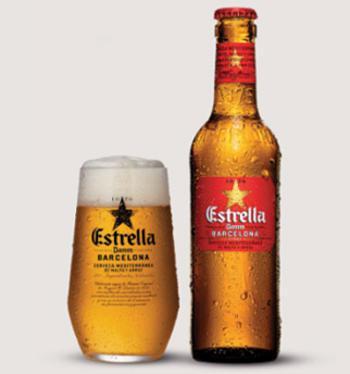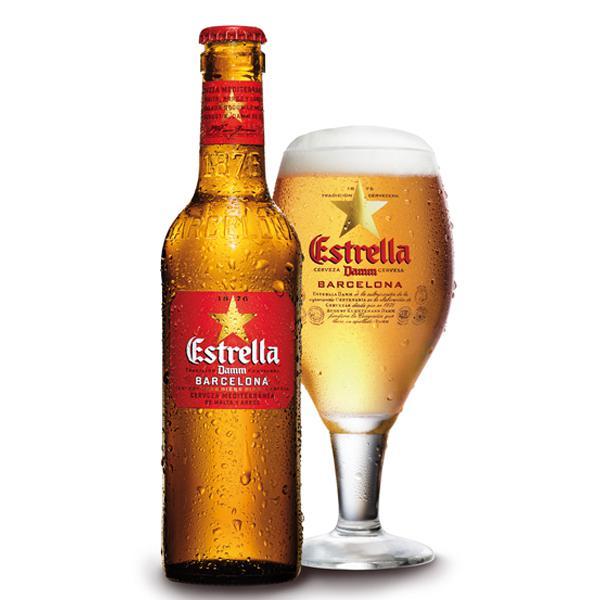The first image is the image on the left, the second image is the image on the right. Given the left and right images, does the statement "Right and left images show the same number of bottles." hold true? Answer yes or no. Yes. The first image is the image on the left, the second image is the image on the right. Given the left and right images, does the statement "There are no more than five beer bottles" hold true? Answer yes or no. Yes. 